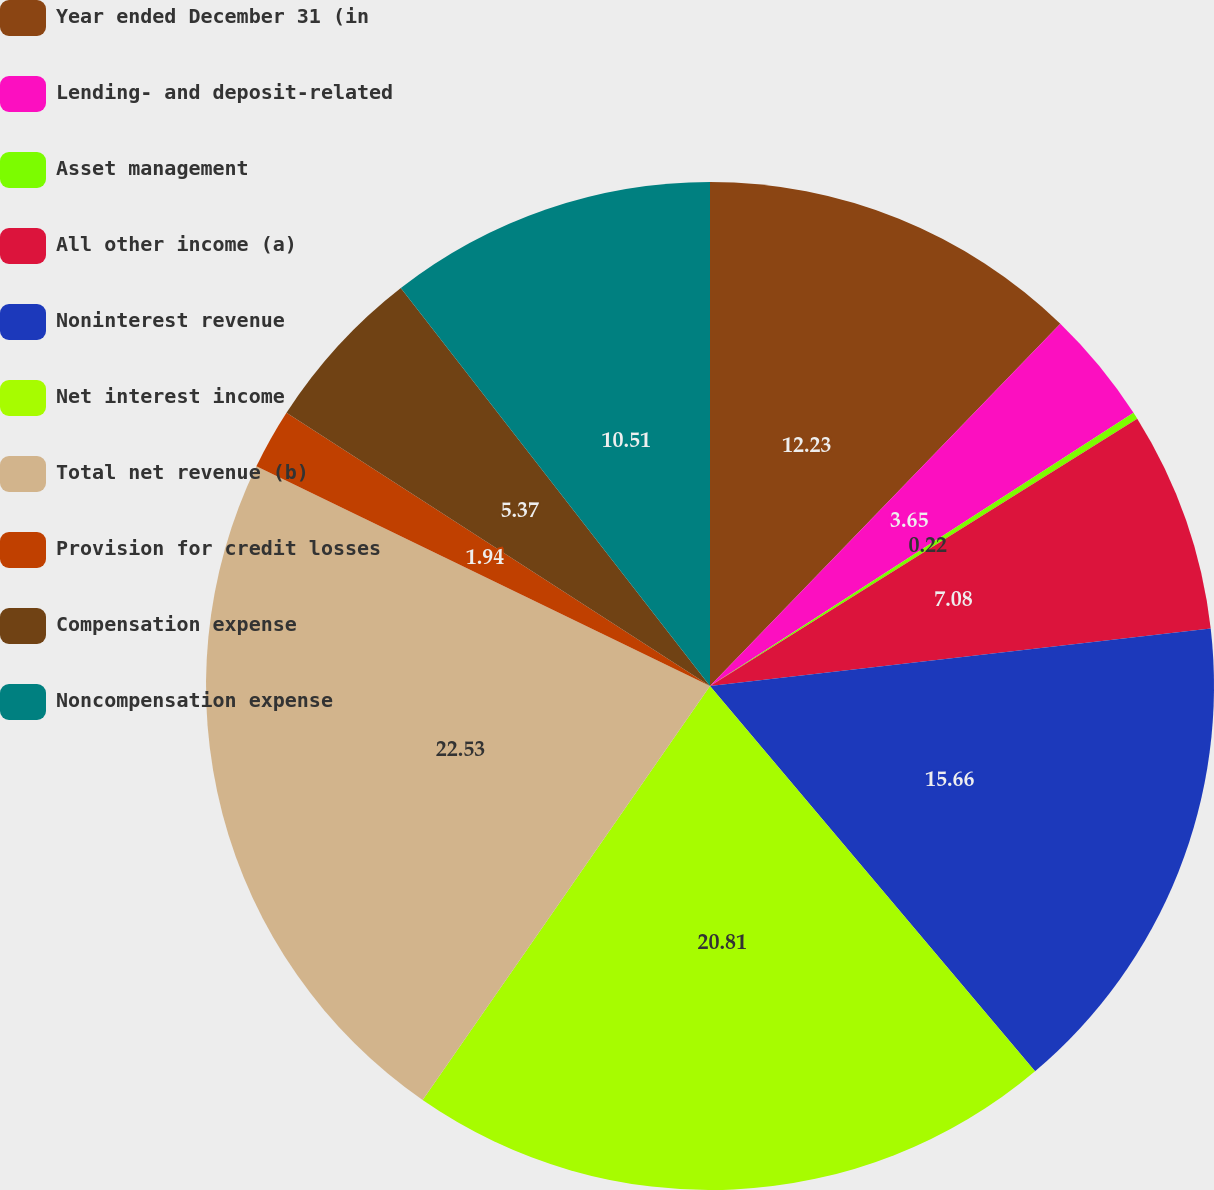Convert chart. <chart><loc_0><loc_0><loc_500><loc_500><pie_chart><fcel>Year ended December 31 (in<fcel>Lending- and deposit-related<fcel>Asset management<fcel>All other income (a)<fcel>Noninterest revenue<fcel>Net interest income<fcel>Total net revenue (b)<fcel>Provision for credit losses<fcel>Compensation expense<fcel>Noncompensation expense<nl><fcel>12.23%<fcel>3.65%<fcel>0.22%<fcel>7.08%<fcel>15.66%<fcel>20.81%<fcel>22.52%<fcel>1.94%<fcel>5.37%<fcel>10.51%<nl></chart> 